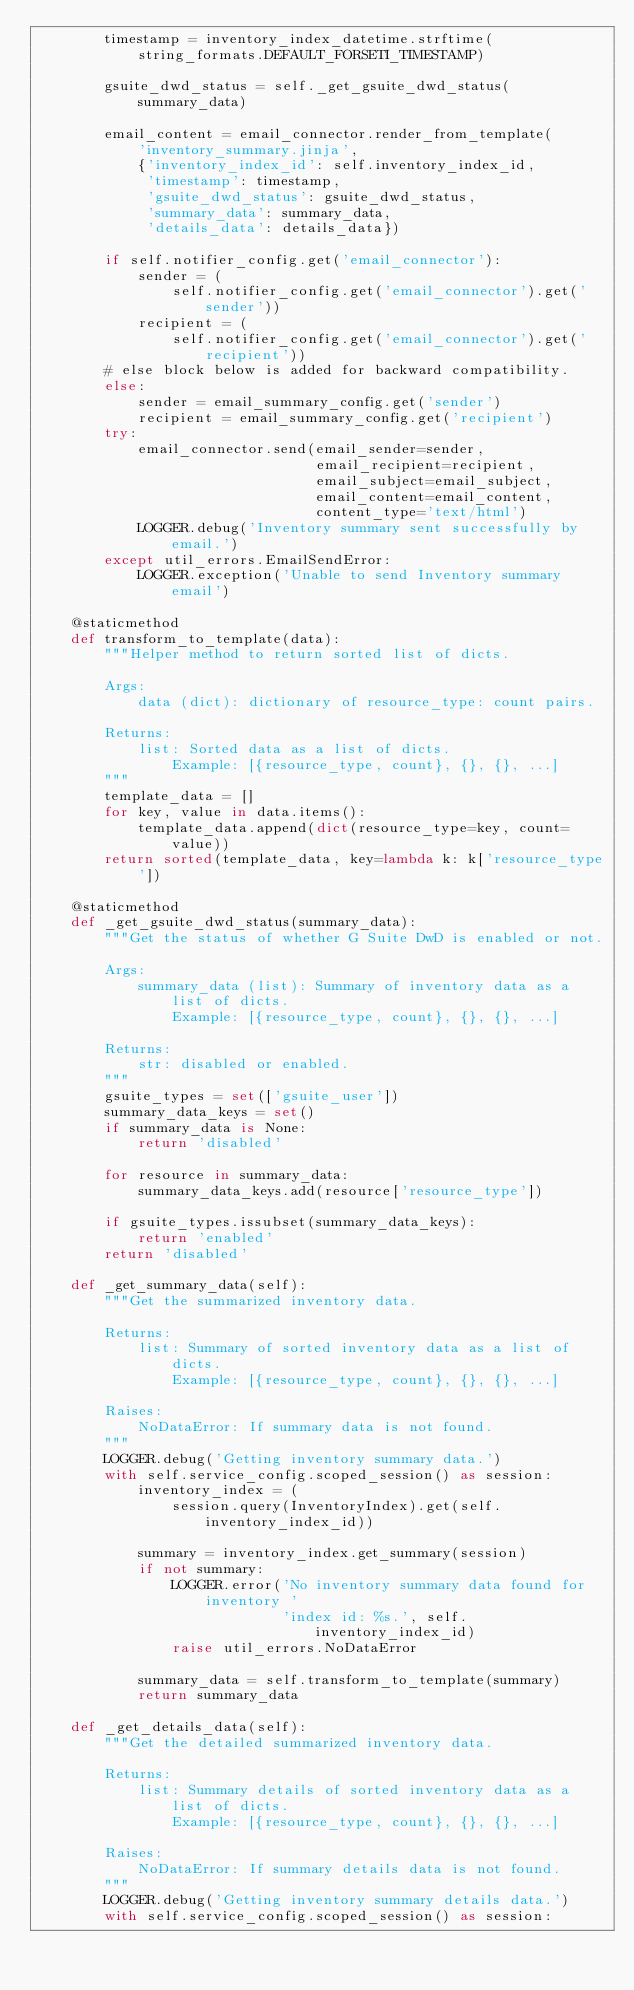Convert code to text. <code><loc_0><loc_0><loc_500><loc_500><_Python_>        timestamp = inventory_index_datetime.strftime(
            string_formats.DEFAULT_FORSETI_TIMESTAMP)

        gsuite_dwd_status = self._get_gsuite_dwd_status(summary_data)

        email_content = email_connector.render_from_template(
            'inventory_summary.jinja',
            {'inventory_index_id': self.inventory_index_id,
             'timestamp': timestamp,
             'gsuite_dwd_status': gsuite_dwd_status,
             'summary_data': summary_data,
             'details_data': details_data})

        if self.notifier_config.get('email_connector'):
            sender = (
                self.notifier_config.get('email_connector').get('sender'))
            recipient = (
                self.notifier_config.get('email_connector').get('recipient'))
        # else block below is added for backward compatibility.
        else:
            sender = email_summary_config.get('sender')
            recipient = email_summary_config.get('recipient')
        try:
            email_connector.send(email_sender=sender,
                                 email_recipient=recipient,
                                 email_subject=email_subject,
                                 email_content=email_content,
                                 content_type='text/html')
            LOGGER.debug('Inventory summary sent successfully by email.')
        except util_errors.EmailSendError:
            LOGGER.exception('Unable to send Inventory summary email')

    @staticmethod
    def transform_to_template(data):
        """Helper method to return sorted list of dicts.

        Args:
            data (dict): dictionary of resource_type: count pairs.

        Returns:
            list: Sorted data as a list of dicts.
                Example: [{resource_type, count}, {}, {}, ...]
        """
        template_data = []
        for key, value in data.items():
            template_data.append(dict(resource_type=key, count=value))
        return sorted(template_data, key=lambda k: k['resource_type'])

    @staticmethod
    def _get_gsuite_dwd_status(summary_data):
        """Get the status of whether G Suite DwD is enabled or not.

        Args:
            summary_data (list): Summary of inventory data as a list of dicts.
                Example: [{resource_type, count}, {}, {}, ...]

        Returns:
            str: disabled or enabled.
        """
        gsuite_types = set(['gsuite_user'])
        summary_data_keys = set()
        if summary_data is None:
            return 'disabled'

        for resource in summary_data:
            summary_data_keys.add(resource['resource_type'])

        if gsuite_types.issubset(summary_data_keys):
            return 'enabled'
        return 'disabled'

    def _get_summary_data(self):
        """Get the summarized inventory data.

        Returns:
            list: Summary of sorted inventory data as a list of dicts.
                Example: [{resource_type, count}, {}, {}, ...]

        Raises:
            NoDataError: If summary data is not found.
        """
        LOGGER.debug('Getting inventory summary data.')
        with self.service_config.scoped_session() as session:
            inventory_index = (
                session.query(InventoryIndex).get(self.inventory_index_id))

            summary = inventory_index.get_summary(session)
            if not summary:
                LOGGER.error('No inventory summary data found for inventory '
                             'index id: %s.', self.inventory_index_id)
                raise util_errors.NoDataError

            summary_data = self.transform_to_template(summary)
            return summary_data

    def _get_details_data(self):
        """Get the detailed summarized inventory data.

        Returns:
            list: Summary details of sorted inventory data as a list of dicts.
                Example: [{resource_type, count}, {}, {}, ...]

        Raises:
            NoDataError: If summary details data is not found.
        """
        LOGGER.debug('Getting inventory summary details data.')
        with self.service_config.scoped_session() as session:</code> 